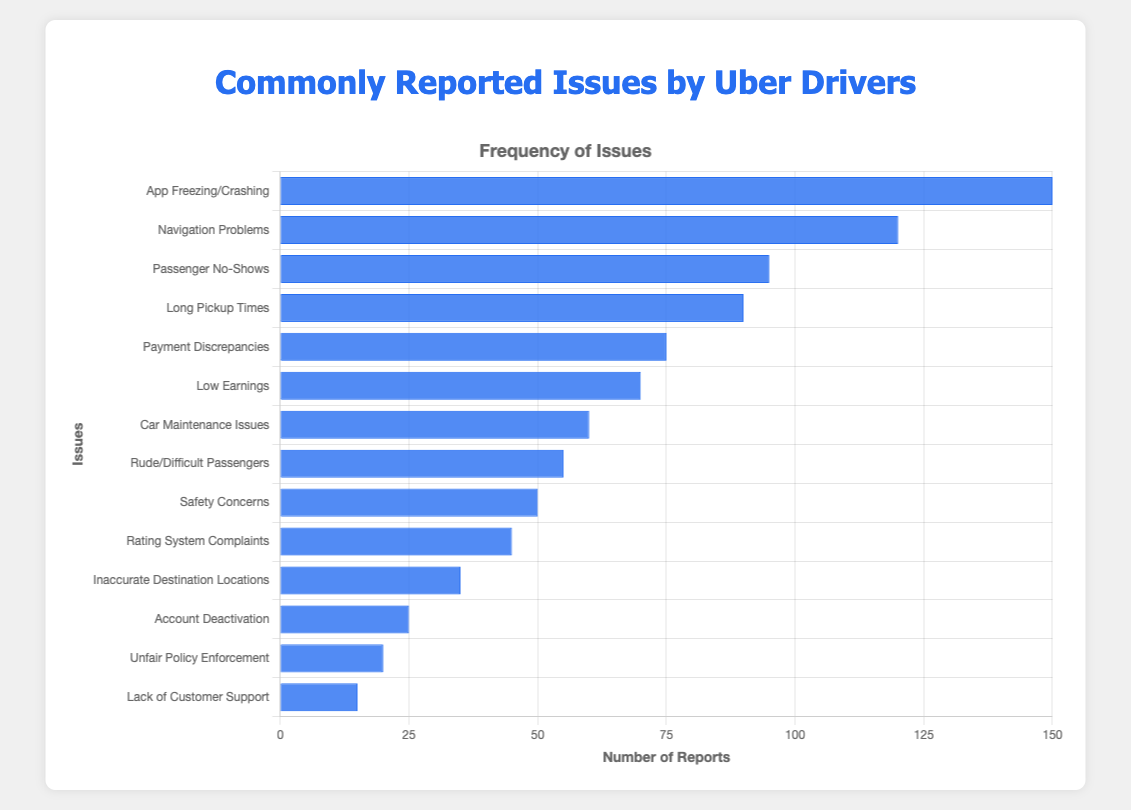Which issue is reported most frequently? The usage of a horizontal bar chart allows us to quickly and easily identify the longest bar. The longest bar corresponds to the issue "App Freezing/Crashing".
Answer: App Freezing/Crashing What is the difference in frequency between the most and least reported issues? The most reported issue is "App Freezing/Crashing" with a frequency of 150, and the least reported issue is "Lack of Customer Support" with a frequency of 15. The difference is calculated as 150 - 15.
Answer: 135 Which issue has a frequency closest to 100? We compare the frequencies and notice that the issue "Passenger No-Shows" has a frequency of 95, which is closest to 100.
Answer: Passenger No-Shows How many issues have a frequency greater than 50? By evaluating the list, we can see the issues with frequencies greater than 50: "App Freezing/Crashing", "Navigation Problems", "Passenger No-Shows", "Long Pickup Times", "Payment Discrepancies", "Low Earnings", "Car Maintenance Issues", and "Rude/Difficult Passengers", totaling 8 issues.
Answer: 8 Which issue has a lower frequency: "Payment Discrepancies" or "Low Earnings"? By comparing the frequencies, we see that "Low Earnings" has a frequency of 70 and "Payment Discrepancies" has a frequency of 75. Therefore, "Low Earnings" has a lower frequency.
Answer: Low Earnings What is the sum of the frequencies of the top 3 reported issues? The top 3 reported issues are "App Freezing/Crashing" (150), "Navigation Problems" (120), and "Passenger No-Shows" (95). Adding these frequencies gives us 150 + 120 + 95.
Answer: 365 What is the average frequency of all reported issues? The sum of all frequencies is (150 + 120 + 95 + 90 + 75 + 70 + 60 + 55 + 50 + 45 + 35 + 25 + 20 + 15) = 905. There are 14 issues in total. The average is calculated as 905 / 14.
Answer: 64.64 By what factor is the frequency of "Navigation Problems" higher than that of "Account Deactivation"? The frequency of "Navigation Problems" is 120, and the frequency of "Account Deactivation" is 25. The factor is 120 / 25.
Answer: 4.8 Is the frequency of "Car Maintenance Issues" higher than "Safety Concerns"? "Car Maintenance Issues" has a frequency of 60, and "Safety Concerns" has a frequency of 50. Since 60 is greater than 50, the frequency of "Car Maintenance Issues" is higher.
Answer: Yes 